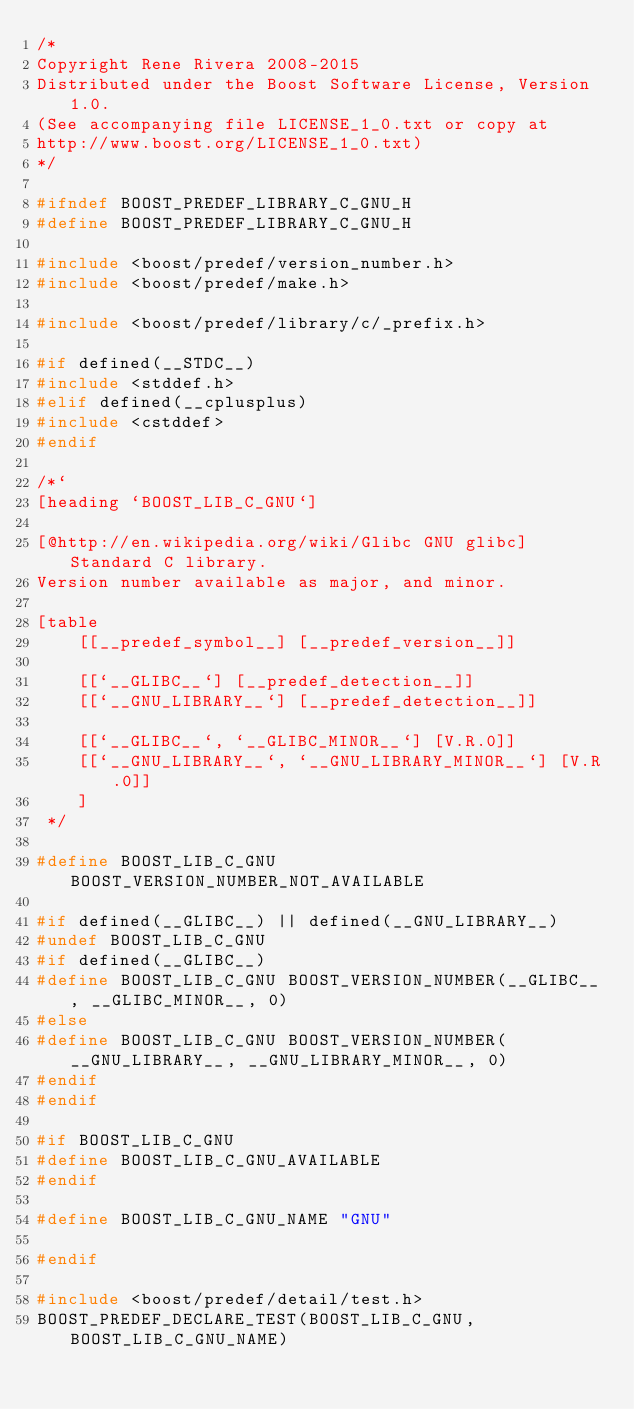Convert code to text. <code><loc_0><loc_0><loc_500><loc_500><_C_>/*
Copyright Rene Rivera 2008-2015
Distributed under the Boost Software License, Version 1.0.
(See accompanying file LICENSE_1_0.txt or copy at
http://www.boost.org/LICENSE_1_0.txt)
*/

#ifndef BOOST_PREDEF_LIBRARY_C_GNU_H
#define BOOST_PREDEF_LIBRARY_C_GNU_H

#include <boost/predef/version_number.h>
#include <boost/predef/make.h>

#include <boost/predef/library/c/_prefix.h>

#if defined(__STDC__)
#include <stddef.h>
#elif defined(__cplusplus)
#include <cstddef>
#endif

/*`
[heading `BOOST_LIB_C_GNU`]

[@http://en.wikipedia.org/wiki/Glibc GNU glibc] Standard C library.
Version number available as major, and minor.

[table
    [[__predef_symbol__] [__predef_version__]]

    [[`__GLIBC__`] [__predef_detection__]]
    [[`__GNU_LIBRARY__`] [__predef_detection__]]

    [[`__GLIBC__`, `__GLIBC_MINOR__`] [V.R.0]]
    [[`__GNU_LIBRARY__`, `__GNU_LIBRARY_MINOR__`] [V.R.0]]
    ]
 */

#define BOOST_LIB_C_GNU BOOST_VERSION_NUMBER_NOT_AVAILABLE

#if defined(__GLIBC__) || defined(__GNU_LIBRARY__)
#undef BOOST_LIB_C_GNU
#if defined(__GLIBC__)
#define BOOST_LIB_C_GNU BOOST_VERSION_NUMBER(__GLIBC__, __GLIBC_MINOR__, 0)
#else
#define BOOST_LIB_C_GNU BOOST_VERSION_NUMBER(__GNU_LIBRARY__, __GNU_LIBRARY_MINOR__, 0)
#endif
#endif

#if BOOST_LIB_C_GNU
#define BOOST_LIB_C_GNU_AVAILABLE
#endif

#define BOOST_LIB_C_GNU_NAME "GNU"

#endif

#include <boost/predef/detail/test.h>
BOOST_PREDEF_DECLARE_TEST(BOOST_LIB_C_GNU, BOOST_LIB_C_GNU_NAME)
</code> 